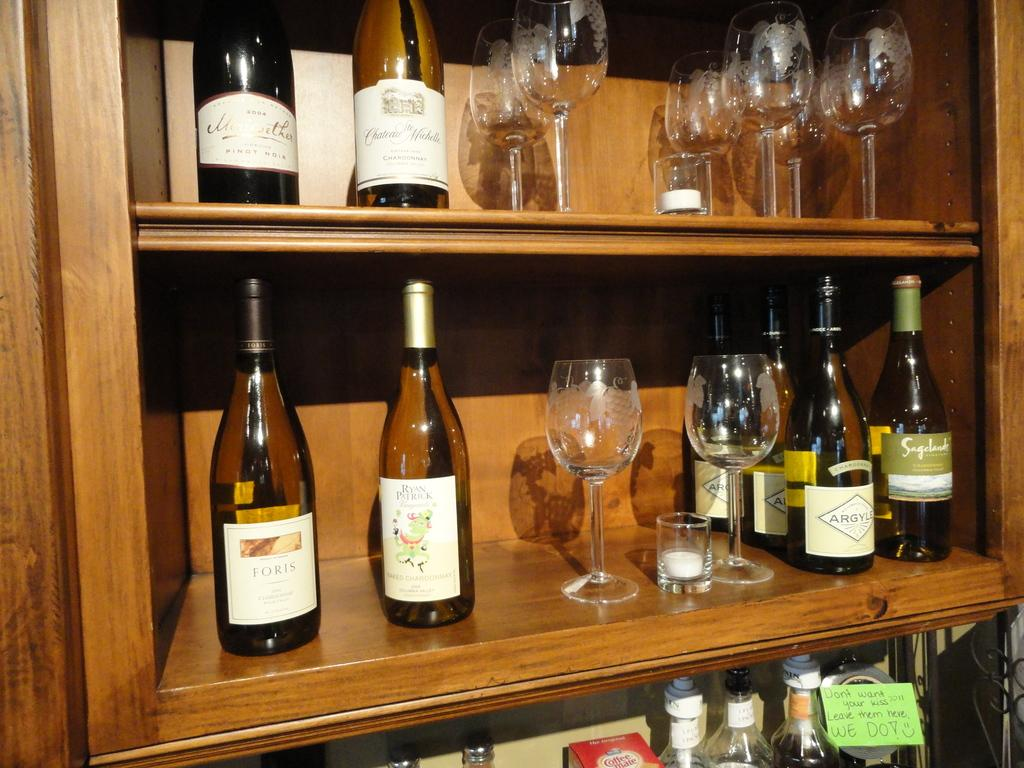<image>
Give a short and clear explanation of the subsequent image. A shelf has wine bottles on it and one of them says Foris. 